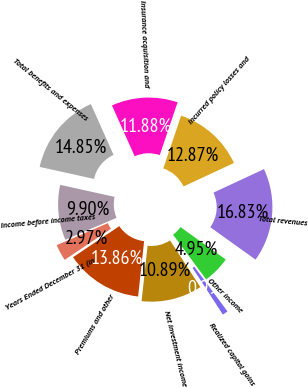Convert chart to OTSL. <chart><loc_0><loc_0><loc_500><loc_500><pie_chart><fcel>Years Ended December 31 (in<fcel>Premiums and other<fcel>Net investment income<fcel>Realized capital gains<fcel>Other income<fcel>Total revenues<fcel>Incurred policy losses and<fcel>Insurance acquisition and<fcel>Total benefits and expenses<fcel>Income before income taxes<nl><fcel>2.97%<fcel>13.86%<fcel>10.89%<fcel>0.99%<fcel>4.95%<fcel>16.83%<fcel>12.87%<fcel>11.88%<fcel>14.85%<fcel>9.9%<nl></chart> 